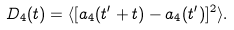<formula> <loc_0><loc_0><loc_500><loc_500>D _ { 4 } ( t ) = \langle [ a _ { 4 } ( t ^ { \prime } + t ) - a _ { 4 } ( t ^ { \prime } ) ] ^ { 2 } \rangle .</formula> 